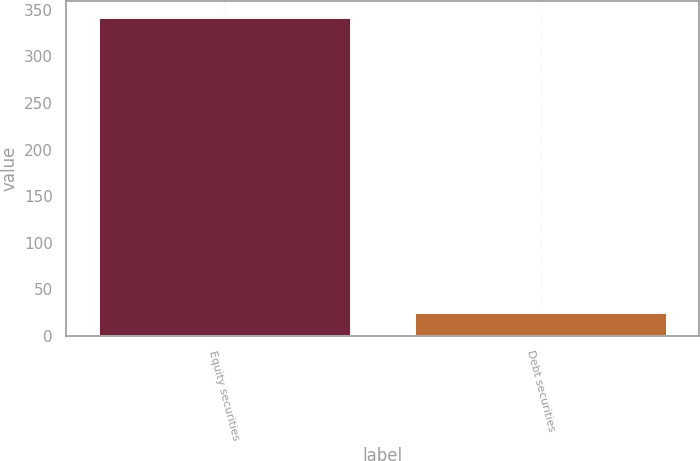Convert chart to OTSL. <chart><loc_0><loc_0><loc_500><loc_500><bar_chart><fcel>Equity securities<fcel>Debt securities<nl><fcel>342<fcel>26<nl></chart> 